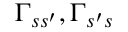Convert formula to latex. <formula><loc_0><loc_0><loc_500><loc_500>\Gamma _ { s s ^ { \prime } } , \Gamma _ { s ^ { \prime } s }</formula> 